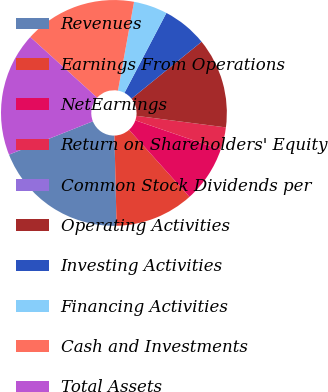<chart> <loc_0><loc_0><loc_500><loc_500><pie_chart><fcel>Revenues<fcel>Earnings From Operations<fcel>NetEarnings<fcel>Return on Shareholders' Equity<fcel>Common Stock Dividends per<fcel>Operating Activities<fcel>Investing Activities<fcel>Financing Activities<fcel>Cash and Investments<fcel>Total Assets<nl><fcel>19.35%<fcel>11.29%<fcel>8.06%<fcel>3.23%<fcel>0.0%<fcel>12.9%<fcel>6.45%<fcel>4.84%<fcel>16.13%<fcel>17.74%<nl></chart> 